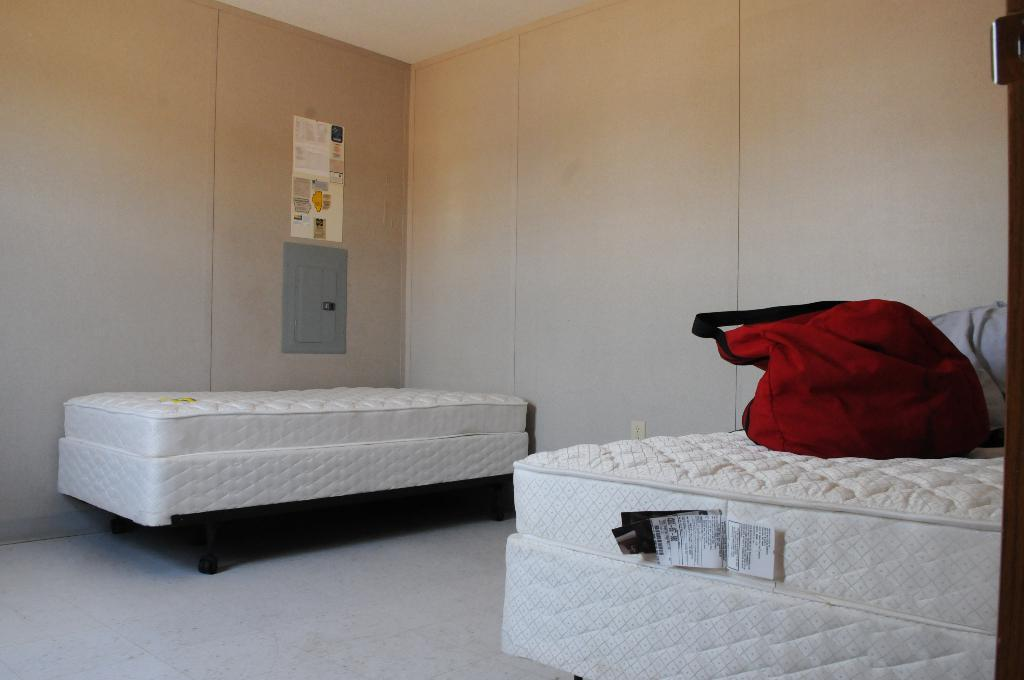What is located on the left side of the image? There is a bed on the left side of the image. What is located on the right side of the image? There is a bed on the right side of the right side of the image. What is placed on the bed on the right side? There is a bag on the right side bed. What can be seen in the background of the image? There is a wall in the background of the image. What type of quill is being used to write on the wall in the image? There is no quill or writing on the wall present in the image. What type of authority is depicted in the image? There is no depiction of authority in the image. 